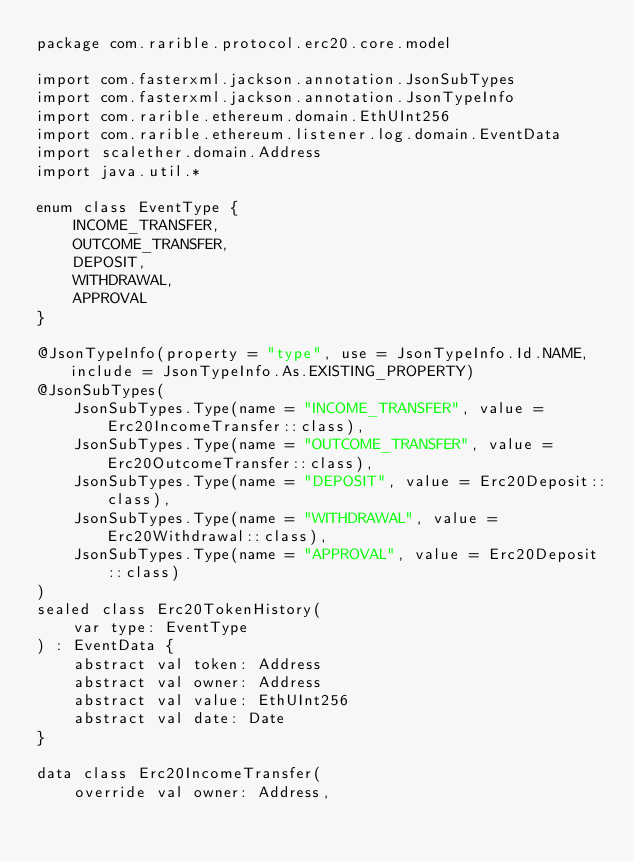<code> <loc_0><loc_0><loc_500><loc_500><_Kotlin_>package com.rarible.protocol.erc20.core.model

import com.fasterxml.jackson.annotation.JsonSubTypes
import com.fasterxml.jackson.annotation.JsonTypeInfo
import com.rarible.ethereum.domain.EthUInt256
import com.rarible.ethereum.listener.log.domain.EventData
import scalether.domain.Address
import java.util.*

enum class EventType {
    INCOME_TRANSFER,
    OUTCOME_TRANSFER,
    DEPOSIT,
    WITHDRAWAL,
    APPROVAL
}

@JsonTypeInfo(property = "type", use = JsonTypeInfo.Id.NAME, include = JsonTypeInfo.As.EXISTING_PROPERTY)
@JsonSubTypes(
    JsonSubTypes.Type(name = "INCOME_TRANSFER", value = Erc20IncomeTransfer::class),
    JsonSubTypes.Type(name = "OUTCOME_TRANSFER", value = Erc20OutcomeTransfer::class),
    JsonSubTypes.Type(name = "DEPOSIT", value = Erc20Deposit::class),
    JsonSubTypes.Type(name = "WITHDRAWAL", value = Erc20Withdrawal::class),
    JsonSubTypes.Type(name = "APPROVAL", value = Erc20Deposit::class)
)
sealed class Erc20TokenHistory(
    var type: EventType
) : EventData {
    abstract val token: Address
    abstract val owner: Address
    abstract val value: EthUInt256
    abstract val date: Date
}

data class Erc20IncomeTransfer(
    override val owner: Address,</code> 